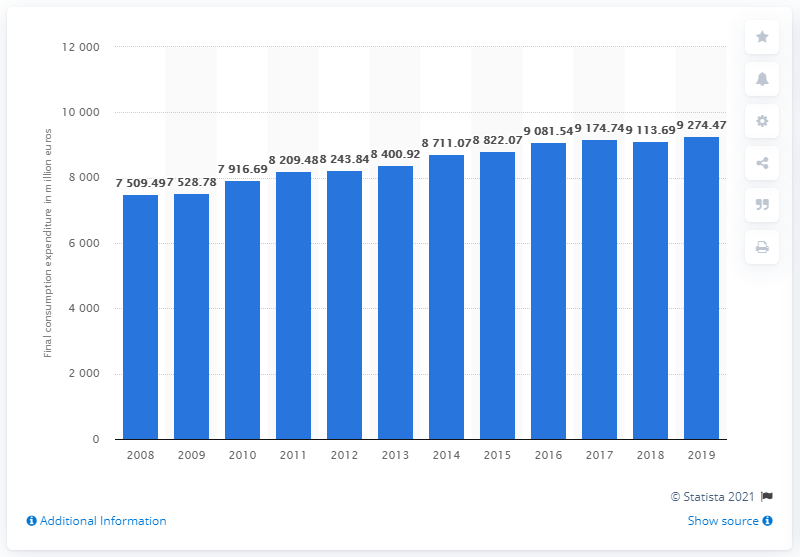Give some essential details in this illustration. In 2019, the spending on clothing in Austria was 7,528.78 euros. In 2008, the spending on clothing in Austria was 7,528.78. 